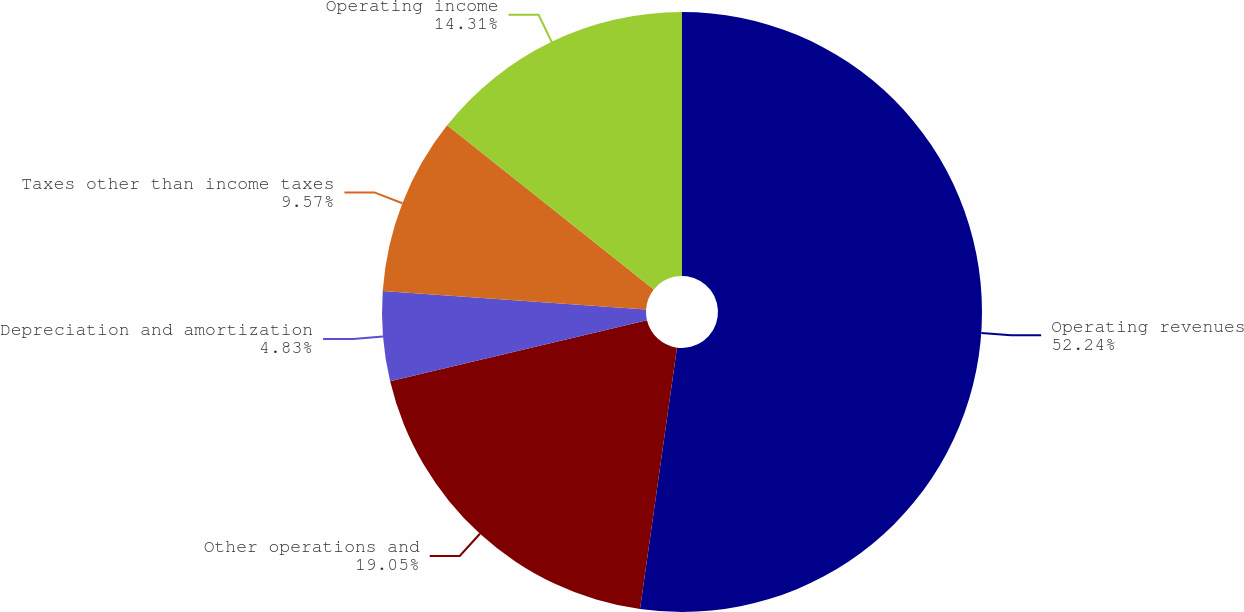Convert chart to OTSL. <chart><loc_0><loc_0><loc_500><loc_500><pie_chart><fcel>Operating revenues<fcel>Other operations and<fcel>Depreciation and amortization<fcel>Taxes other than income taxes<fcel>Operating income<nl><fcel>52.23%<fcel>19.05%<fcel>4.83%<fcel>9.57%<fcel>14.31%<nl></chart> 